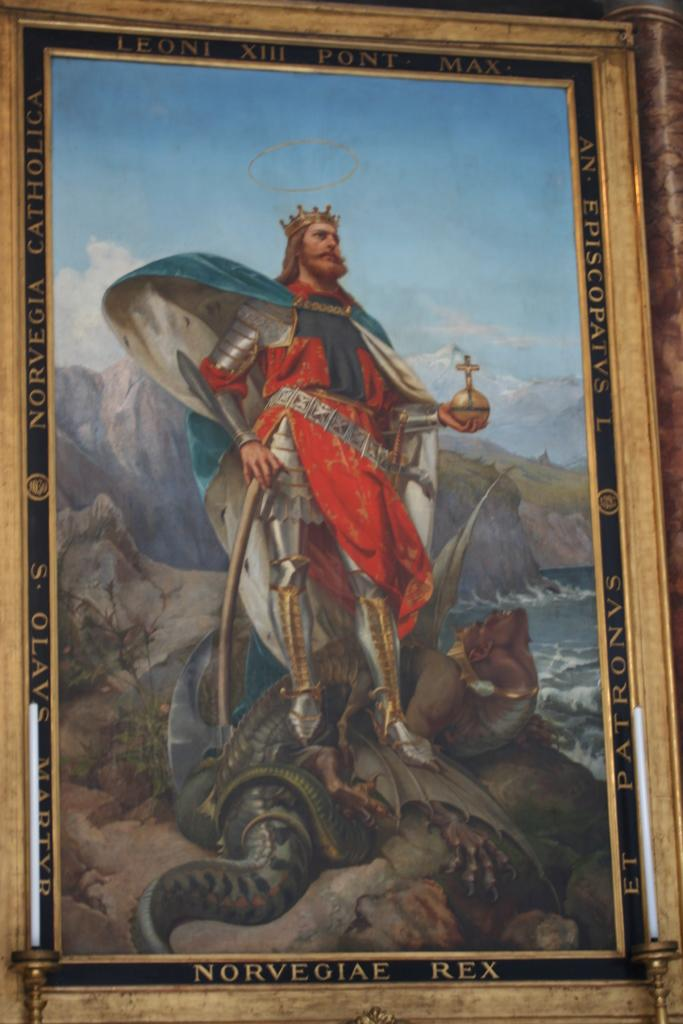<image>
Relay a brief, clear account of the picture shown. A painting of a man in a crown with the words Norvegiae Rex on the bottom of the frame. 